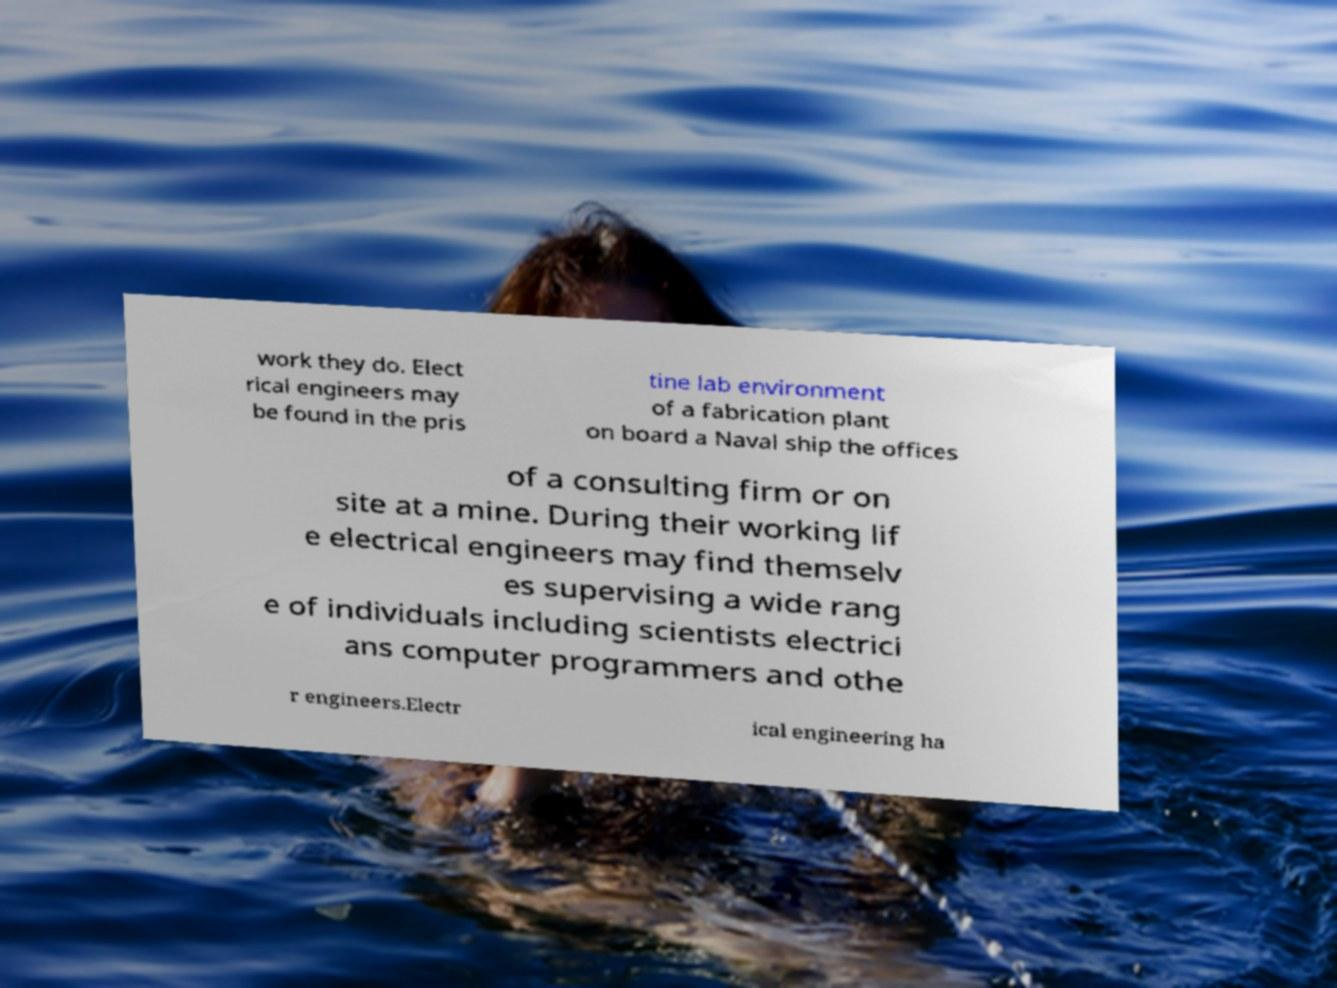There's text embedded in this image that I need extracted. Can you transcribe it verbatim? work they do. Elect rical engineers may be found in the pris tine lab environment of a fabrication plant on board a Naval ship the offices of a consulting firm or on site at a mine. During their working lif e electrical engineers may find themselv es supervising a wide rang e of individuals including scientists electrici ans computer programmers and othe r engineers.Electr ical engineering ha 